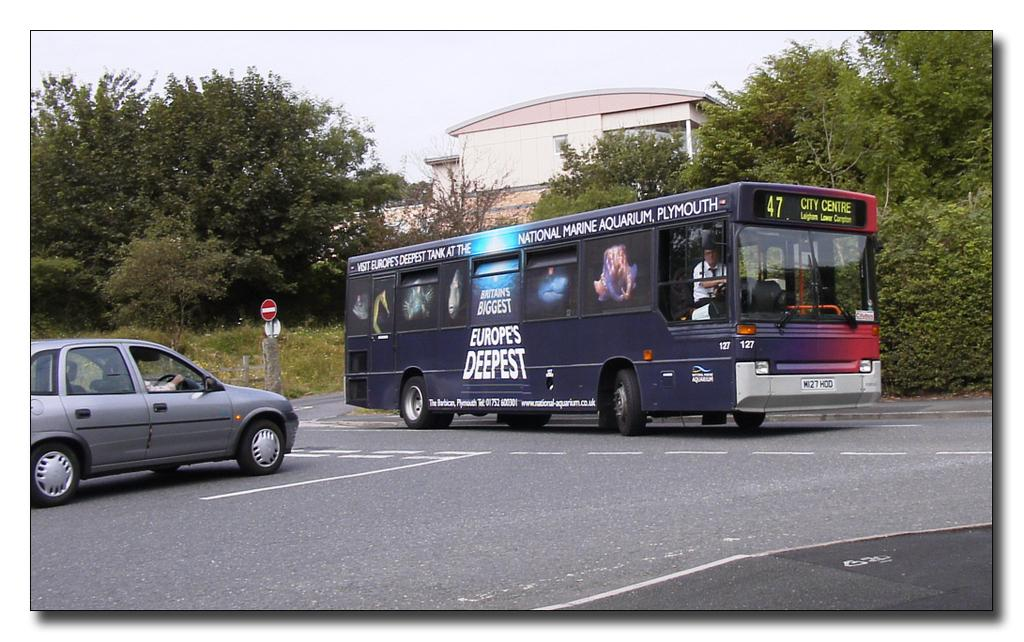What is the main feature of the image? There is a road in the image. What vehicles can be seen on the road? There is a bus and a car on the road. What type of vegetation is present around the road? There are plants and trees around the road. What can be seen in the background of the image? There is a building in the background of the image. Where is the bed located in the image? There is no bed present in the image. What type of pain is the person in the image experiencing? There is no person in the image, and therefore no indication of any pain. 